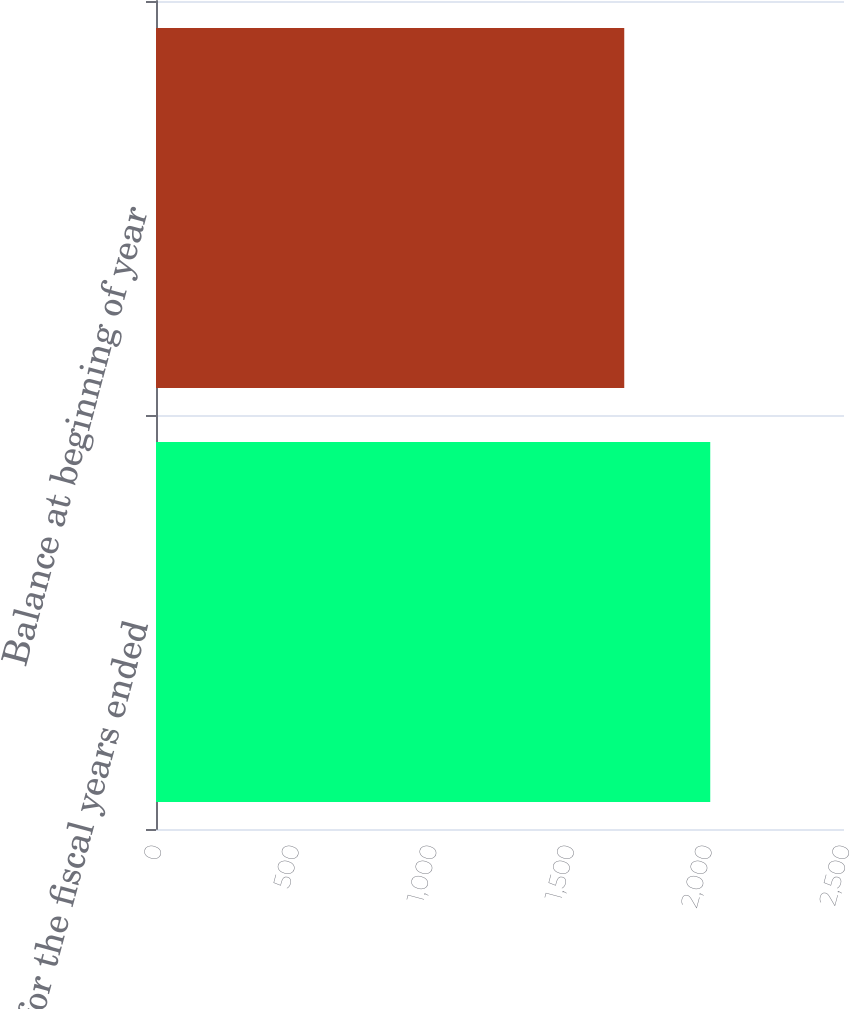<chart> <loc_0><loc_0><loc_500><loc_500><bar_chart><fcel>for the fiscal years ended<fcel>Balance at beginning of year<nl><fcel>2014<fcel>1701.5<nl></chart> 